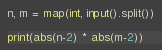<code> <loc_0><loc_0><loc_500><loc_500><_Python_>n, m = map(int, input().split())

print(abs(n-2) * abs(m-2))</code> 